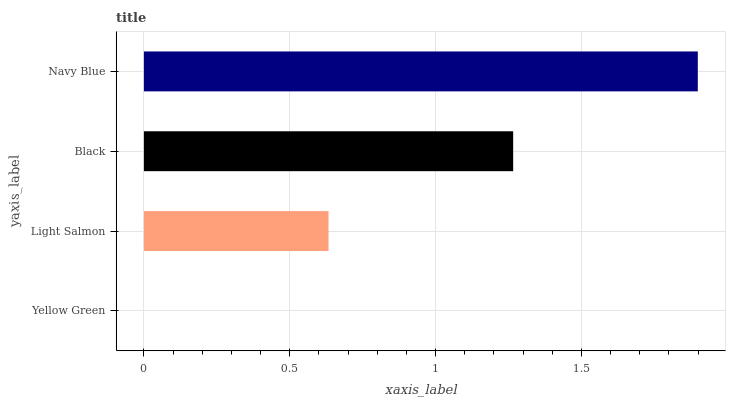Is Yellow Green the minimum?
Answer yes or no. Yes. Is Navy Blue the maximum?
Answer yes or no. Yes. Is Light Salmon the minimum?
Answer yes or no. No. Is Light Salmon the maximum?
Answer yes or no. No. Is Light Salmon greater than Yellow Green?
Answer yes or no. Yes. Is Yellow Green less than Light Salmon?
Answer yes or no. Yes. Is Yellow Green greater than Light Salmon?
Answer yes or no. No. Is Light Salmon less than Yellow Green?
Answer yes or no. No. Is Black the high median?
Answer yes or no. Yes. Is Light Salmon the low median?
Answer yes or no. Yes. Is Light Salmon the high median?
Answer yes or no. No. Is Black the low median?
Answer yes or no. No. 